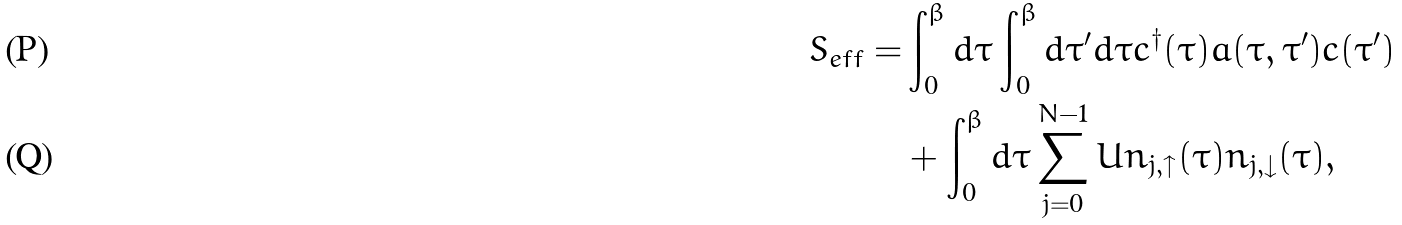Convert formula to latex. <formula><loc_0><loc_0><loc_500><loc_500>S _ { e f f } = & \int _ { 0 } ^ { \beta } d \tau \int _ { 0 } ^ { \beta } d \tau ^ { \prime } d \tau c ^ { \dagger } ( \tau ) { a } ( \tau , \tau ^ { \prime } ) c ( \tau ^ { \prime } ) \\ & + \int _ { 0 } ^ { \beta } d \tau \sum _ { j = 0 } ^ { N - 1 } U n _ { j , \uparrow } ( \tau ) n _ { j , \downarrow } ( \tau ) ,</formula> 